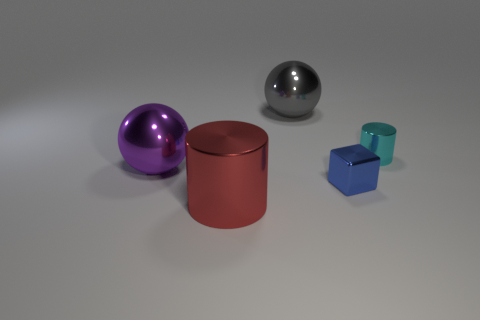Subtract all brown cylinders. Subtract all red blocks. How many cylinders are left? 2 Add 1 red cylinders. How many objects exist? 6 Subtract all cylinders. How many objects are left? 3 Subtract 0 blue spheres. How many objects are left? 5 Subtract all blue blocks. Subtract all purple shiny spheres. How many objects are left? 3 Add 5 large red things. How many large red things are left? 6 Add 5 small cyan shiny cylinders. How many small cyan shiny cylinders exist? 6 